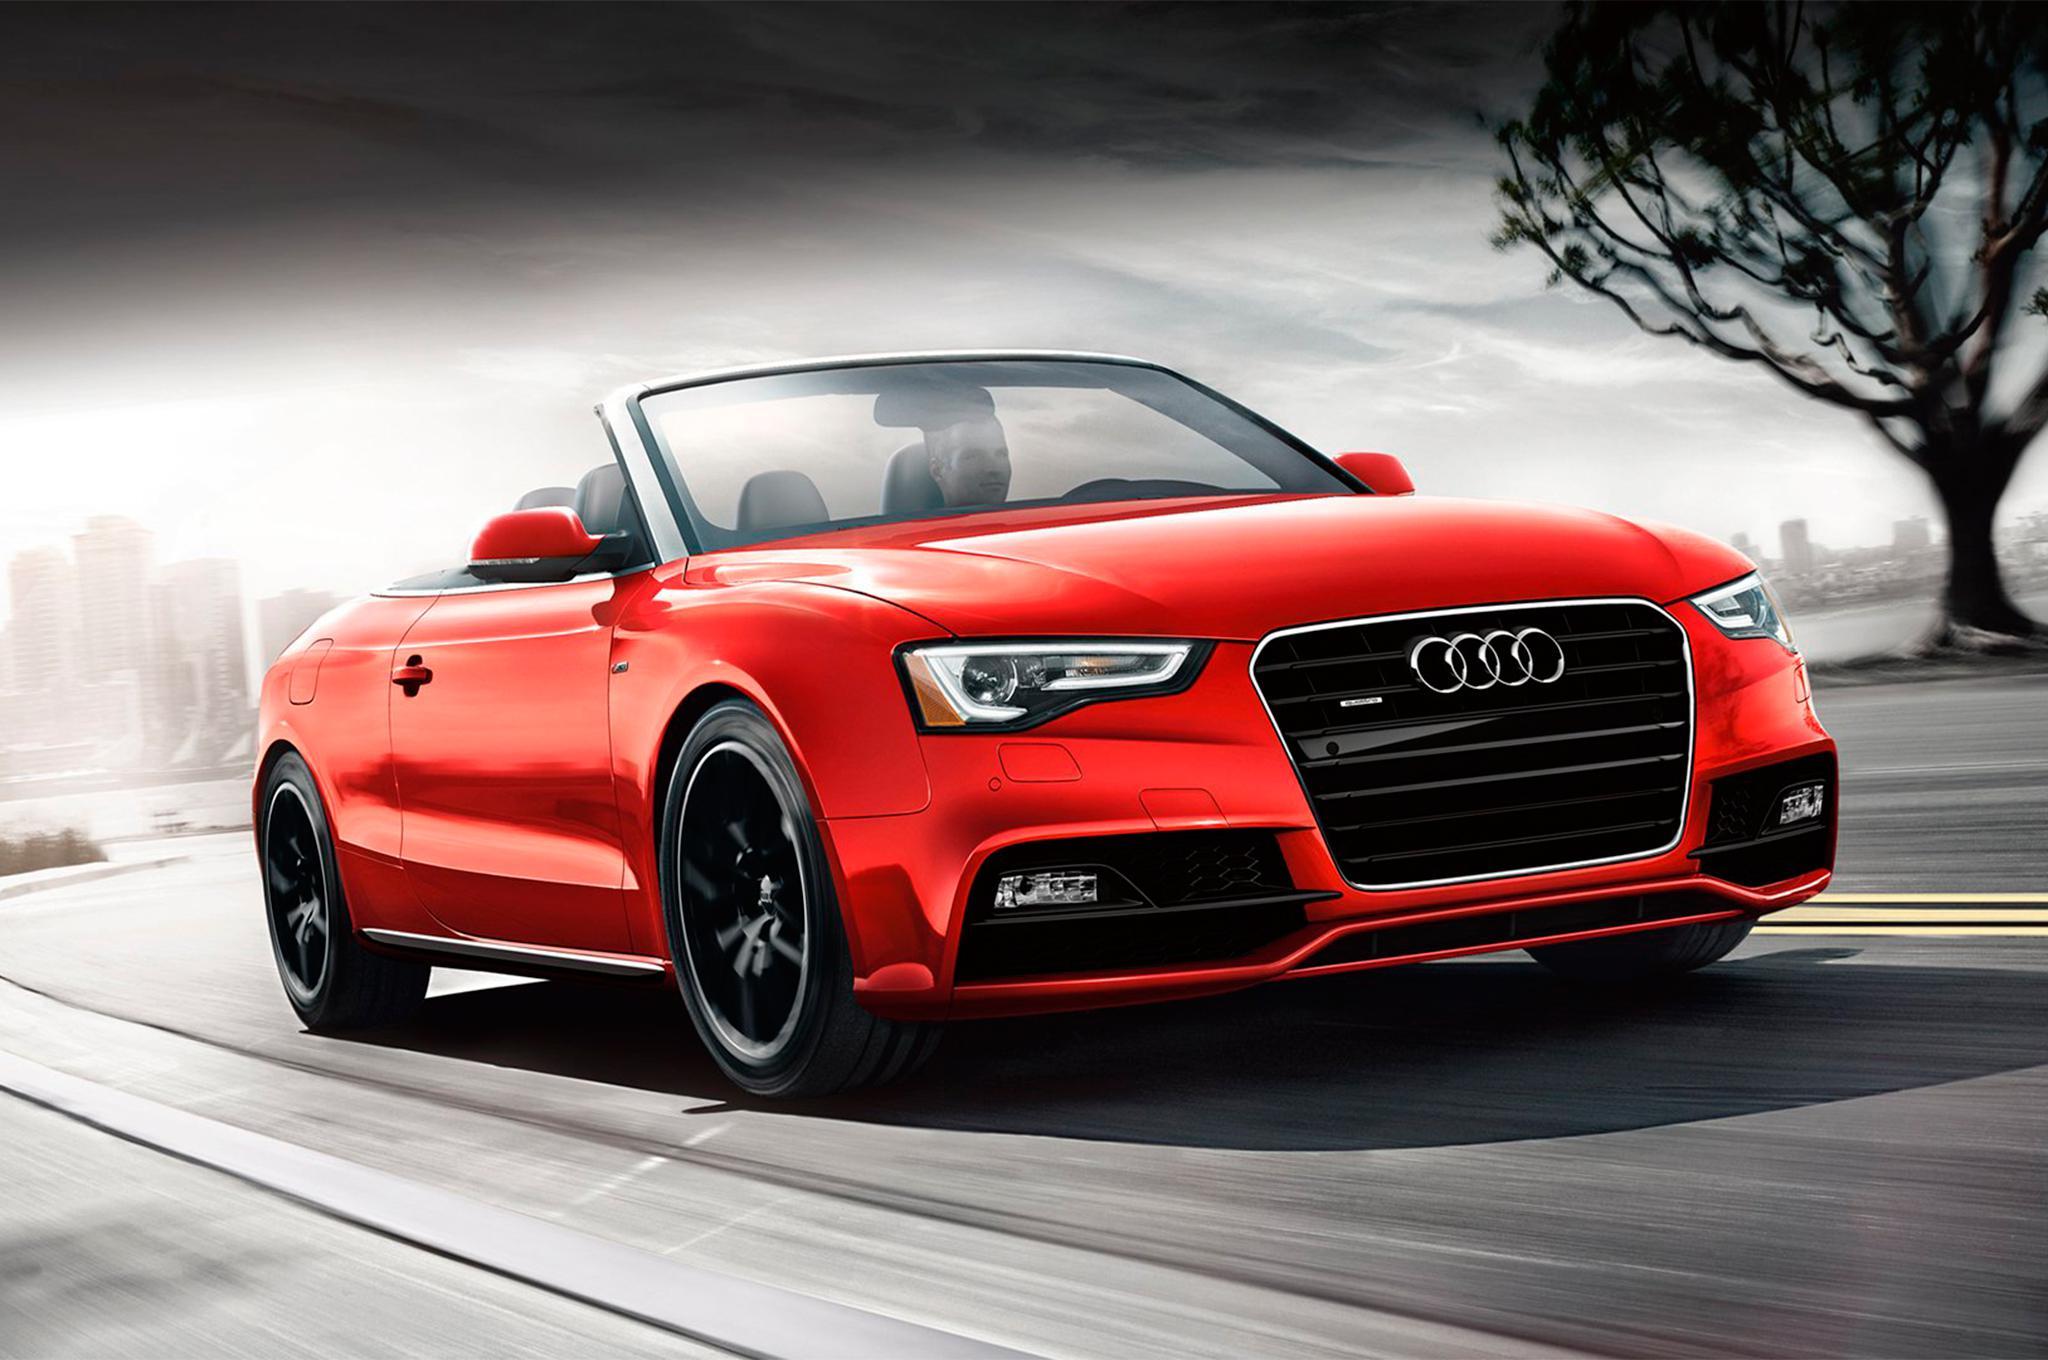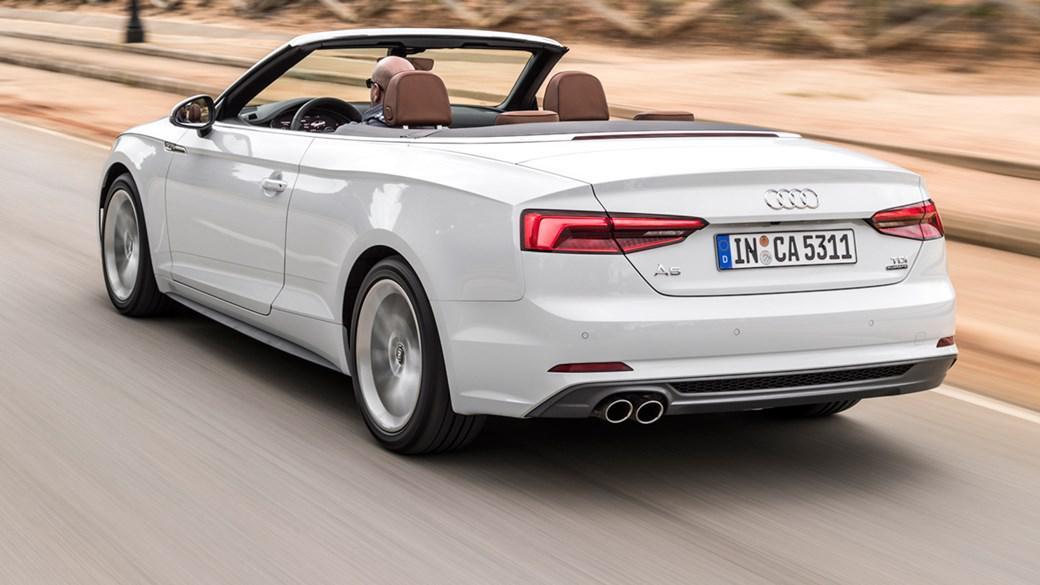The first image is the image on the left, the second image is the image on the right. Assess this claim about the two images: "There is at least one car facing towards the right side.". Correct or not? Answer yes or no. Yes. The first image is the image on the left, the second image is the image on the right. Given the left and right images, does the statement "The combined images include a topless white convertible with its rear to the camera moving leftward, and a topless convertible facing forward." hold true? Answer yes or no. Yes. 